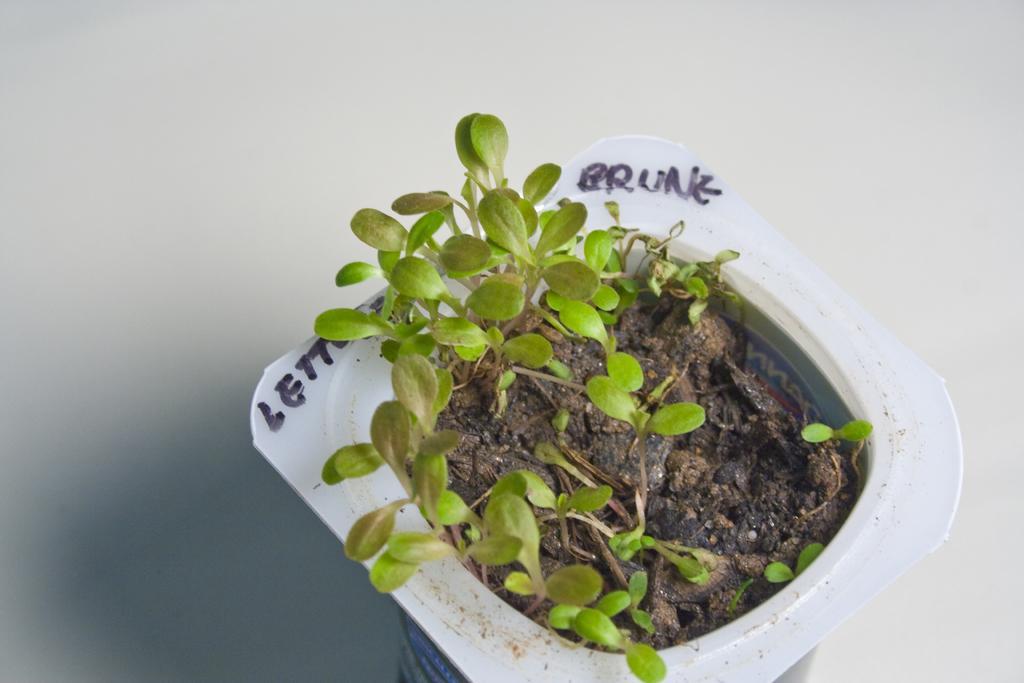In one or two sentences, can you explain what this image depicts? In this image we can see plants in a container placed on the surface. 